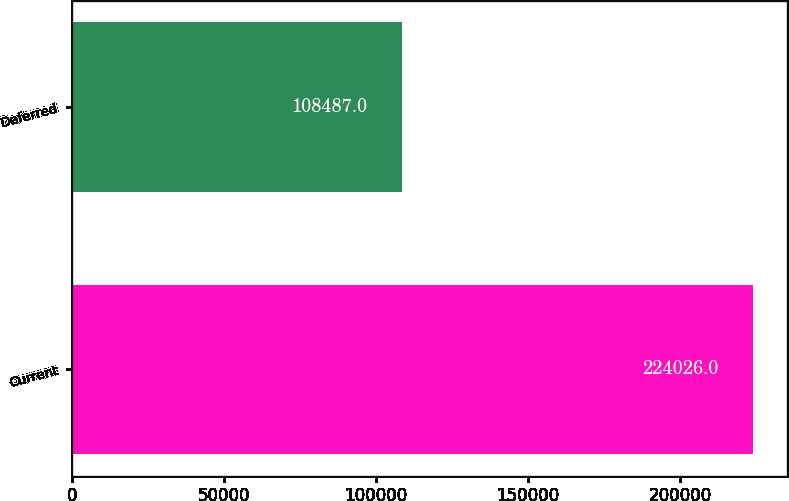Convert chart. <chart><loc_0><loc_0><loc_500><loc_500><bar_chart><fcel>Current<fcel>Deferred<nl><fcel>224026<fcel>108487<nl></chart> 